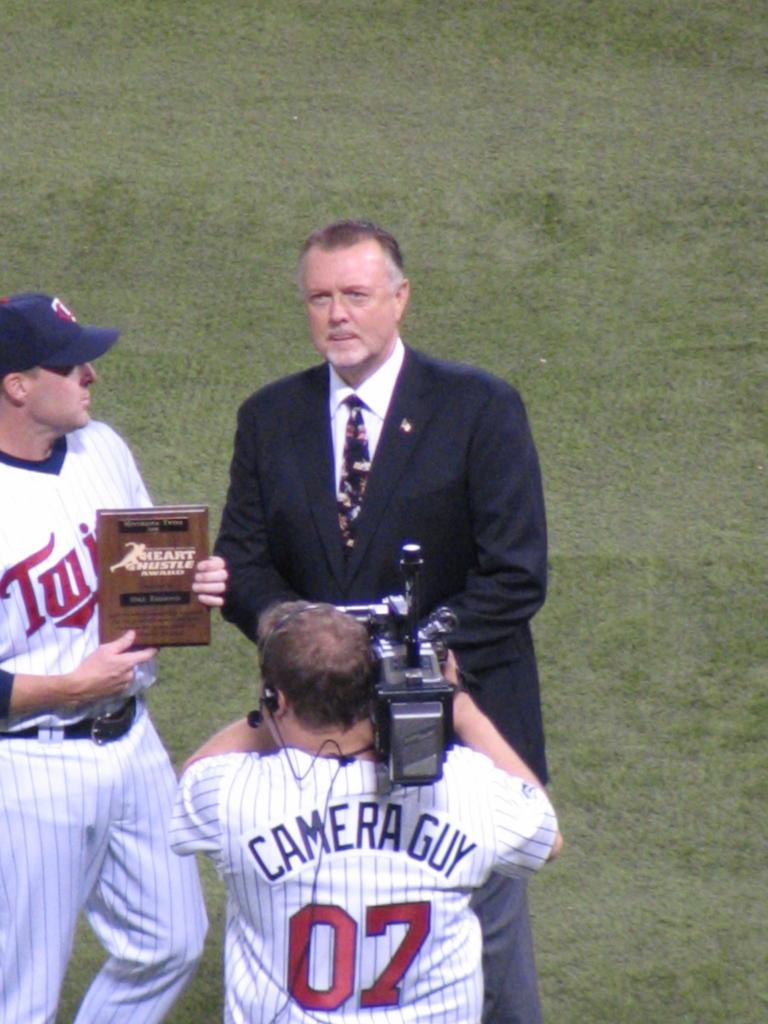<image>
Present a compact description of the photo's key features. The Heart Hustle award is being presented to a man in a suit by a Twins baseball player. 